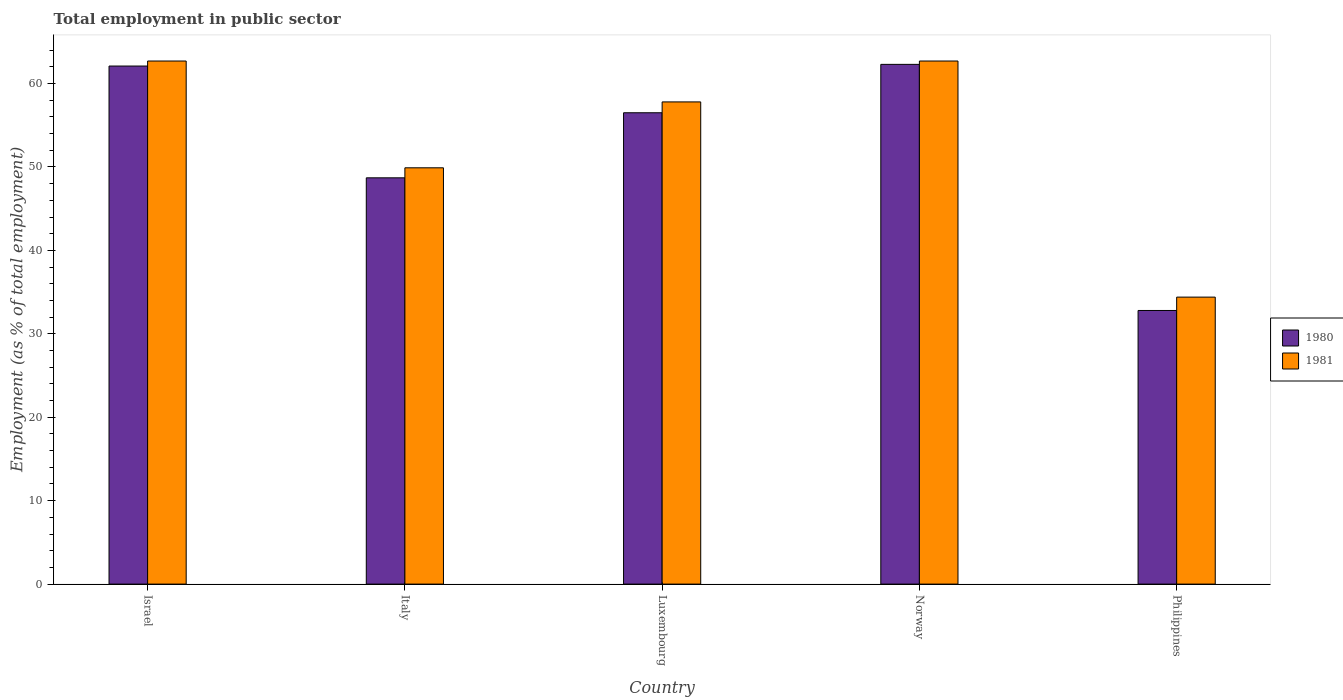How many different coloured bars are there?
Offer a terse response. 2. How many bars are there on the 4th tick from the left?
Your answer should be compact. 2. In how many cases, is the number of bars for a given country not equal to the number of legend labels?
Your answer should be very brief. 0. What is the employment in public sector in 1980 in Italy?
Give a very brief answer. 48.7. Across all countries, what is the maximum employment in public sector in 1980?
Make the answer very short. 62.3. Across all countries, what is the minimum employment in public sector in 1980?
Ensure brevity in your answer.  32.8. What is the total employment in public sector in 1980 in the graph?
Provide a short and direct response. 262.4. What is the difference between the employment in public sector in 1981 in Israel and that in Italy?
Give a very brief answer. 12.8. What is the difference between the employment in public sector in 1980 in Norway and the employment in public sector in 1981 in Italy?
Make the answer very short. 12.4. What is the average employment in public sector in 1980 per country?
Ensure brevity in your answer.  52.48. What is the difference between the employment in public sector of/in 1980 and employment in public sector of/in 1981 in Luxembourg?
Keep it short and to the point. -1.3. In how many countries, is the employment in public sector in 1980 greater than 48 %?
Offer a very short reply. 4. What is the ratio of the employment in public sector in 1981 in Israel to that in Italy?
Offer a very short reply. 1.26. What is the difference between the highest and the second highest employment in public sector in 1980?
Your answer should be compact. 5.6. What is the difference between the highest and the lowest employment in public sector in 1981?
Your answer should be compact. 28.3. Is the sum of the employment in public sector in 1981 in Israel and Italy greater than the maximum employment in public sector in 1980 across all countries?
Offer a terse response. Yes. What does the 1st bar from the right in Italy represents?
Make the answer very short. 1981. How many countries are there in the graph?
Give a very brief answer. 5. Are the values on the major ticks of Y-axis written in scientific E-notation?
Keep it short and to the point. No. Does the graph contain any zero values?
Offer a terse response. No. Where does the legend appear in the graph?
Provide a succinct answer. Center right. How many legend labels are there?
Your answer should be compact. 2. What is the title of the graph?
Offer a very short reply. Total employment in public sector. What is the label or title of the Y-axis?
Offer a terse response. Employment (as % of total employment). What is the Employment (as % of total employment) in 1980 in Israel?
Ensure brevity in your answer.  62.1. What is the Employment (as % of total employment) in 1981 in Israel?
Ensure brevity in your answer.  62.7. What is the Employment (as % of total employment) of 1980 in Italy?
Provide a succinct answer. 48.7. What is the Employment (as % of total employment) of 1981 in Italy?
Offer a terse response. 49.9. What is the Employment (as % of total employment) of 1980 in Luxembourg?
Your answer should be very brief. 56.5. What is the Employment (as % of total employment) in 1981 in Luxembourg?
Make the answer very short. 57.8. What is the Employment (as % of total employment) in 1980 in Norway?
Your response must be concise. 62.3. What is the Employment (as % of total employment) in 1981 in Norway?
Offer a terse response. 62.7. What is the Employment (as % of total employment) of 1980 in Philippines?
Provide a short and direct response. 32.8. What is the Employment (as % of total employment) of 1981 in Philippines?
Offer a terse response. 34.4. Across all countries, what is the maximum Employment (as % of total employment) in 1980?
Your answer should be compact. 62.3. Across all countries, what is the maximum Employment (as % of total employment) in 1981?
Ensure brevity in your answer.  62.7. Across all countries, what is the minimum Employment (as % of total employment) in 1980?
Keep it short and to the point. 32.8. Across all countries, what is the minimum Employment (as % of total employment) in 1981?
Ensure brevity in your answer.  34.4. What is the total Employment (as % of total employment) of 1980 in the graph?
Keep it short and to the point. 262.4. What is the total Employment (as % of total employment) in 1981 in the graph?
Give a very brief answer. 267.5. What is the difference between the Employment (as % of total employment) in 1980 in Israel and that in Italy?
Ensure brevity in your answer.  13.4. What is the difference between the Employment (as % of total employment) of 1981 in Israel and that in Italy?
Make the answer very short. 12.8. What is the difference between the Employment (as % of total employment) of 1980 in Israel and that in Norway?
Make the answer very short. -0.2. What is the difference between the Employment (as % of total employment) of 1981 in Israel and that in Norway?
Give a very brief answer. 0. What is the difference between the Employment (as % of total employment) in 1980 in Israel and that in Philippines?
Provide a succinct answer. 29.3. What is the difference between the Employment (as % of total employment) of 1981 in Israel and that in Philippines?
Your response must be concise. 28.3. What is the difference between the Employment (as % of total employment) of 1980 in Italy and that in Luxembourg?
Ensure brevity in your answer.  -7.8. What is the difference between the Employment (as % of total employment) of 1981 in Luxembourg and that in Norway?
Ensure brevity in your answer.  -4.9. What is the difference between the Employment (as % of total employment) in 1980 in Luxembourg and that in Philippines?
Give a very brief answer. 23.7. What is the difference between the Employment (as % of total employment) in 1981 in Luxembourg and that in Philippines?
Offer a terse response. 23.4. What is the difference between the Employment (as % of total employment) of 1980 in Norway and that in Philippines?
Provide a short and direct response. 29.5. What is the difference between the Employment (as % of total employment) in 1981 in Norway and that in Philippines?
Provide a short and direct response. 28.3. What is the difference between the Employment (as % of total employment) in 1980 in Israel and the Employment (as % of total employment) in 1981 in Luxembourg?
Make the answer very short. 4.3. What is the difference between the Employment (as % of total employment) of 1980 in Israel and the Employment (as % of total employment) of 1981 in Norway?
Provide a succinct answer. -0.6. What is the difference between the Employment (as % of total employment) in 1980 in Israel and the Employment (as % of total employment) in 1981 in Philippines?
Offer a terse response. 27.7. What is the difference between the Employment (as % of total employment) of 1980 in Italy and the Employment (as % of total employment) of 1981 in Norway?
Make the answer very short. -14. What is the difference between the Employment (as % of total employment) of 1980 in Italy and the Employment (as % of total employment) of 1981 in Philippines?
Your response must be concise. 14.3. What is the difference between the Employment (as % of total employment) in 1980 in Luxembourg and the Employment (as % of total employment) in 1981 in Philippines?
Your answer should be compact. 22.1. What is the difference between the Employment (as % of total employment) of 1980 in Norway and the Employment (as % of total employment) of 1981 in Philippines?
Provide a succinct answer. 27.9. What is the average Employment (as % of total employment) of 1980 per country?
Ensure brevity in your answer.  52.48. What is the average Employment (as % of total employment) of 1981 per country?
Offer a very short reply. 53.5. What is the difference between the Employment (as % of total employment) in 1980 and Employment (as % of total employment) in 1981 in Israel?
Provide a succinct answer. -0.6. What is the difference between the Employment (as % of total employment) of 1980 and Employment (as % of total employment) of 1981 in Norway?
Your answer should be very brief. -0.4. What is the difference between the Employment (as % of total employment) in 1980 and Employment (as % of total employment) in 1981 in Philippines?
Give a very brief answer. -1.6. What is the ratio of the Employment (as % of total employment) of 1980 in Israel to that in Italy?
Give a very brief answer. 1.28. What is the ratio of the Employment (as % of total employment) of 1981 in Israel to that in Italy?
Provide a succinct answer. 1.26. What is the ratio of the Employment (as % of total employment) of 1980 in Israel to that in Luxembourg?
Your response must be concise. 1.1. What is the ratio of the Employment (as % of total employment) in 1981 in Israel to that in Luxembourg?
Make the answer very short. 1.08. What is the ratio of the Employment (as % of total employment) in 1980 in Israel to that in Norway?
Keep it short and to the point. 1. What is the ratio of the Employment (as % of total employment) of 1981 in Israel to that in Norway?
Provide a succinct answer. 1. What is the ratio of the Employment (as % of total employment) of 1980 in Israel to that in Philippines?
Provide a succinct answer. 1.89. What is the ratio of the Employment (as % of total employment) in 1981 in Israel to that in Philippines?
Offer a terse response. 1.82. What is the ratio of the Employment (as % of total employment) of 1980 in Italy to that in Luxembourg?
Provide a succinct answer. 0.86. What is the ratio of the Employment (as % of total employment) in 1981 in Italy to that in Luxembourg?
Offer a very short reply. 0.86. What is the ratio of the Employment (as % of total employment) in 1980 in Italy to that in Norway?
Give a very brief answer. 0.78. What is the ratio of the Employment (as % of total employment) in 1981 in Italy to that in Norway?
Ensure brevity in your answer.  0.8. What is the ratio of the Employment (as % of total employment) in 1980 in Italy to that in Philippines?
Keep it short and to the point. 1.48. What is the ratio of the Employment (as % of total employment) of 1981 in Italy to that in Philippines?
Offer a very short reply. 1.45. What is the ratio of the Employment (as % of total employment) in 1980 in Luxembourg to that in Norway?
Ensure brevity in your answer.  0.91. What is the ratio of the Employment (as % of total employment) of 1981 in Luxembourg to that in Norway?
Your answer should be compact. 0.92. What is the ratio of the Employment (as % of total employment) of 1980 in Luxembourg to that in Philippines?
Provide a short and direct response. 1.72. What is the ratio of the Employment (as % of total employment) of 1981 in Luxembourg to that in Philippines?
Provide a succinct answer. 1.68. What is the ratio of the Employment (as % of total employment) in 1980 in Norway to that in Philippines?
Make the answer very short. 1.9. What is the ratio of the Employment (as % of total employment) in 1981 in Norway to that in Philippines?
Ensure brevity in your answer.  1.82. What is the difference between the highest and the second highest Employment (as % of total employment) of 1980?
Offer a terse response. 0.2. What is the difference between the highest and the second highest Employment (as % of total employment) of 1981?
Provide a short and direct response. 0. What is the difference between the highest and the lowest Employment (as % of total employment) of 1980?
Make the answer very short. 29.5. What is the difference between the highest and the lowest Employment (as % of total employment) in 1981?
Ensure brevity in your answer.  28.3. 